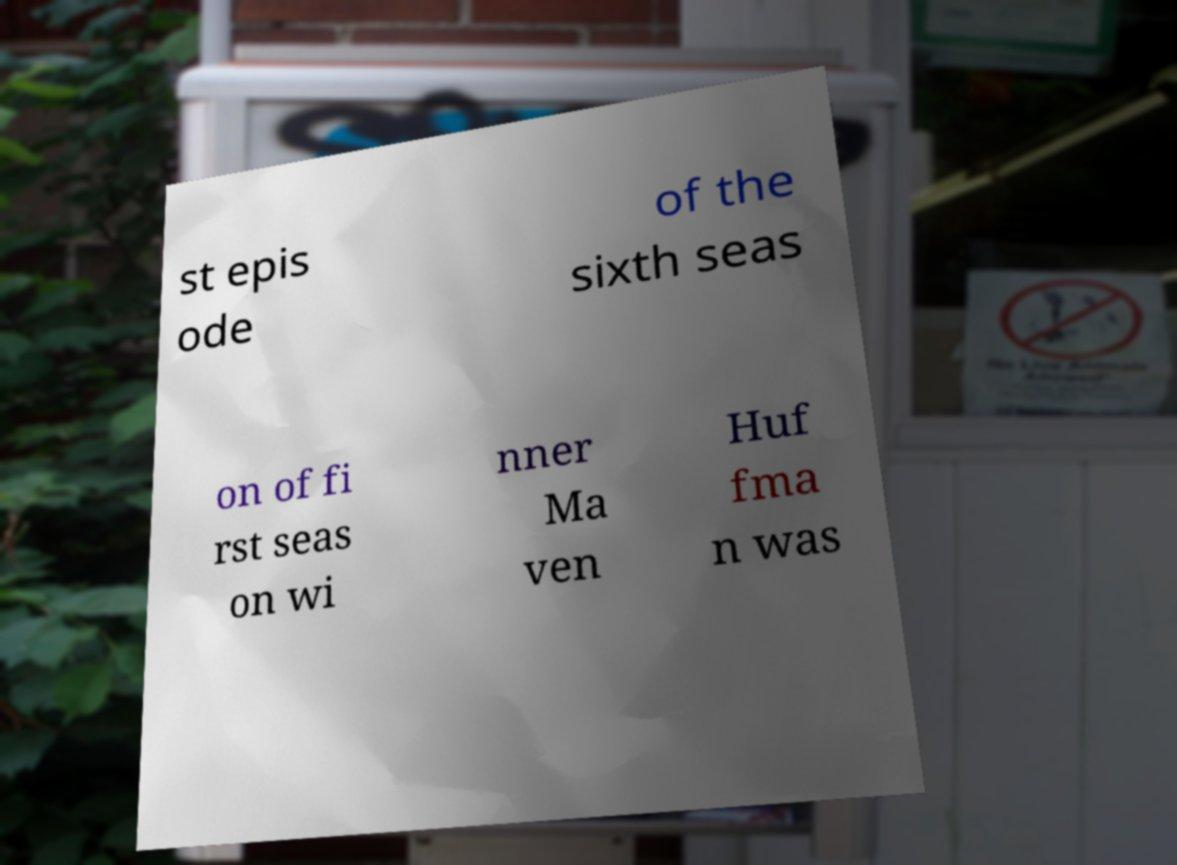Please identify and transcribe the text found in this image. st epis ode of the sixth seas on of fi rst seas on wi nner Ma ven Huf fma n was 